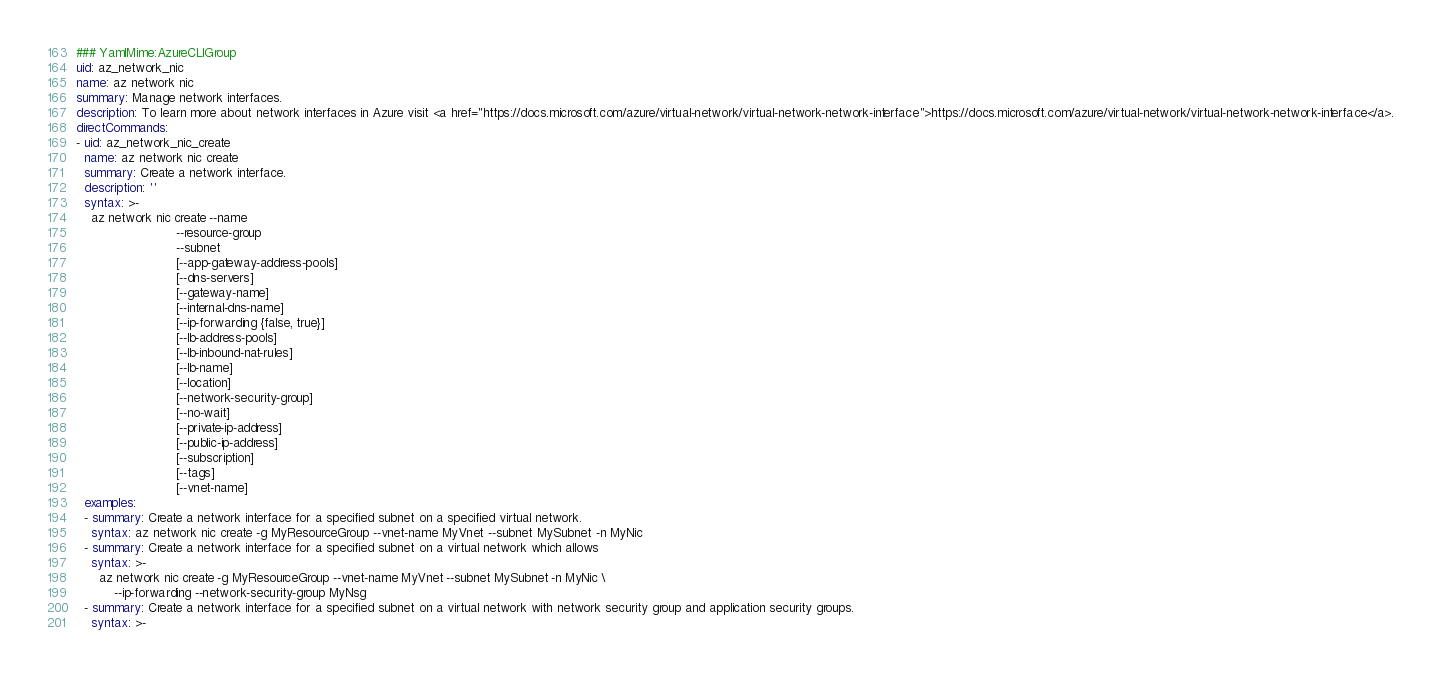Convert code to text. <code><loc_0><loc_0><loc_500><loc_500><_YAML_>### YamlMime:AzureCLIGroup
uid: az_network_nic
name: az network nic
summary: Manage network interfaces.
description: To learn more about network interfaces in Azure visit <a href="https://docs.microsoft.com/azure/virtual-network/virtual-network-network-interface">https://docs.microsoft.com/azure/virtual-network/virtual-network-network-interface</a>.
directCommands:
- uid: az_network_nic_create
  name: az network nic create
  summary: Create a network interface.
  description: ''
  syntax: >-
    az network nic create --name
                          --resource-group
                          --subnet
                          [--app-gateway-address-pools]
                          [--dns-servers]
                          [--gateway-name]
                          [--internal-dns-name]
                          [--ip-forwarding {false, true}]
                          [--lb-address-pools]
                          [--lb-inbound-nat-rules]
                          [--lb-name]
                          [--location]
                          [--network-security-group]
                          [--no-wait]
                          [--private-ip-address]
                          [--public-ip-address]
                          [--subscription]
                          [--tags]
                          [--vnet-name]
  examples:
  - summary: Create a network interface for a specified subnet on a specified virtual network.
    syntax: az network nic create -g MyResourceGroup --vnet-name MyVnet --subnet MySubnet -n MyNic
  - summary: Create a network interface for a specified subnet on a virtual network which allows
    syntax: >-
      az network nic create -g MyResourceGroup --vnet-name MyVnet --subnet MySubnet -n MyNic \
          --ip-forwarding --network-security-group MyNsg
  - summary: Create a network interface for a specified subnet on a virtual network with network security group and application security groups.
    syntax: >-</code> 